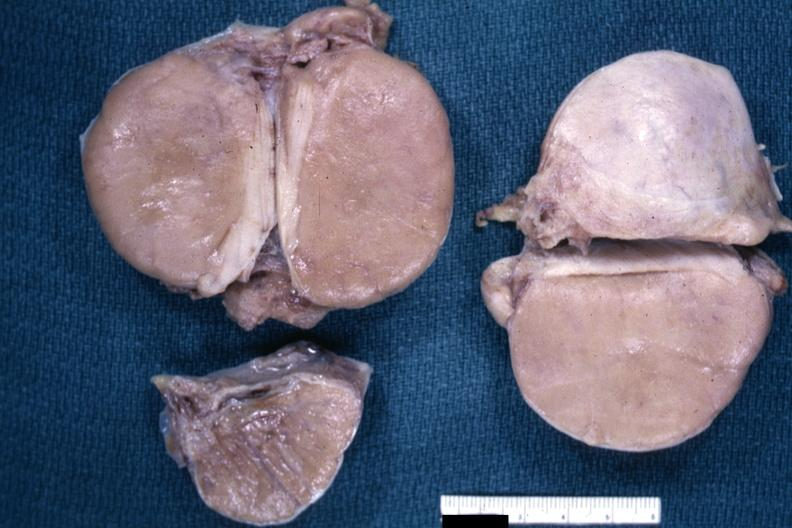what does this image show?
Answer the question using a single word or phrase. Fixed tissue i think discrete lesion well shown 